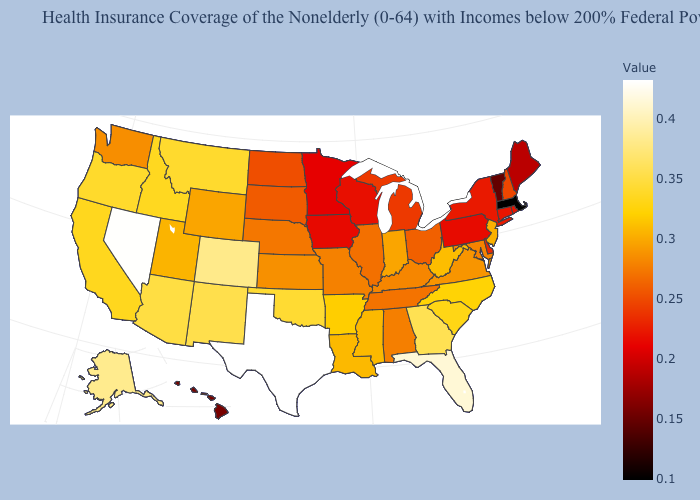Which states hav the highest value in the West?
Keep it brief. Nevada. Which states have the lowest value in the USA?
Short answer required. Massachusetts. Does Texas have the highest value in the USA?
Quick response, please. Yes. Does the map have missing data?
Be succinct. No. Does North Carolina have the highest value in the South?
Keep it brief. No. 